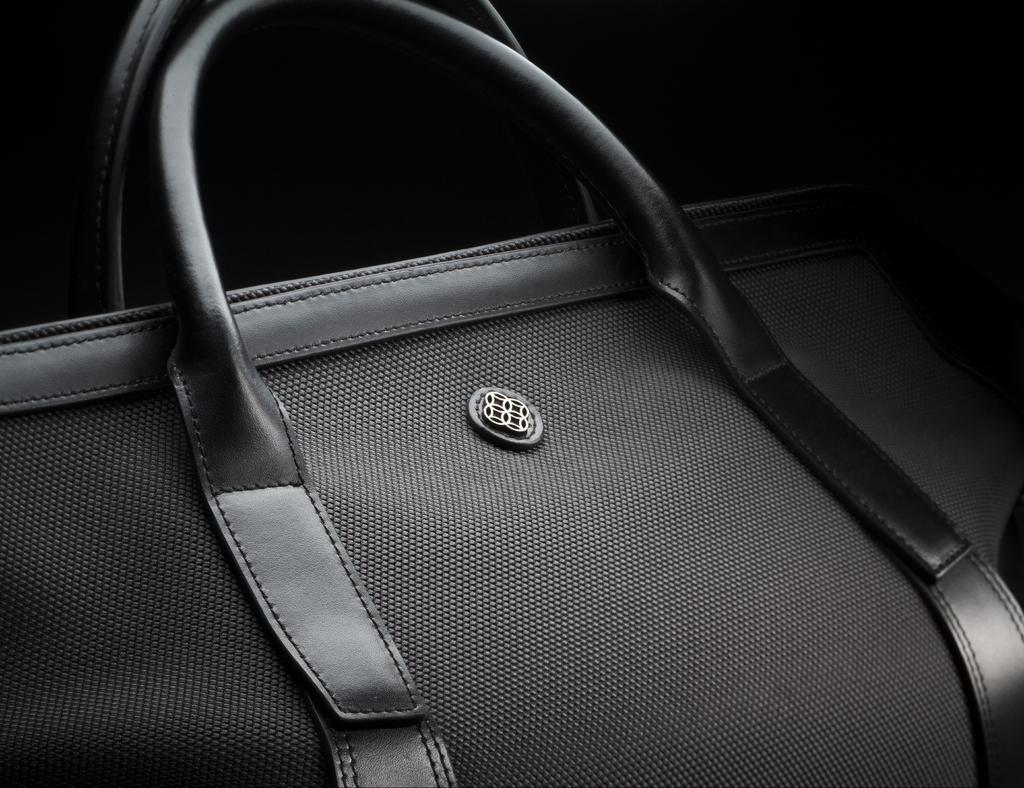What object can be seen in the image? There is a handbag in the image. Can you describe the handbag in more detail? Unfortunately, the image only shows a handbag, and no further details are provided. What might the handbag be made of? The material of the handbag cannot be determined from the image alone. What type of pet is sitting on the page in the image? There is no pet or page present in the image; it only features a handbag. 